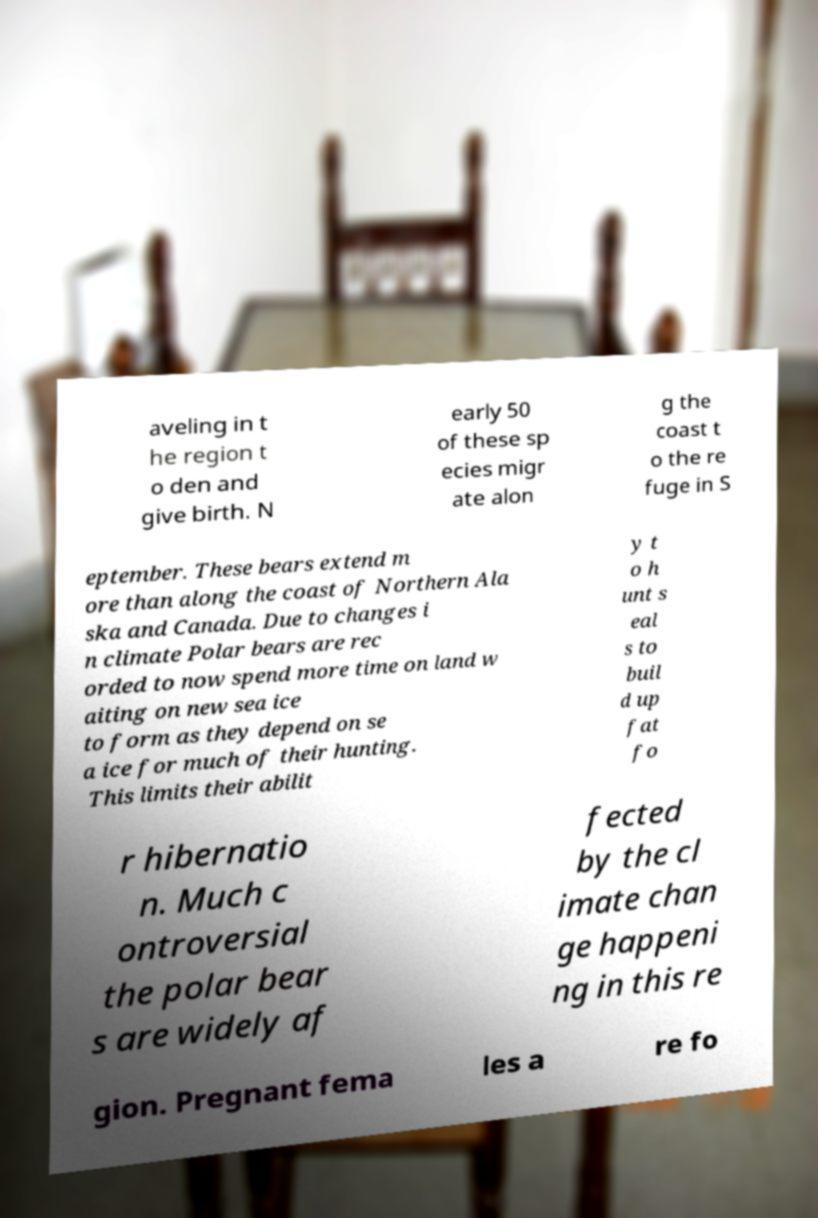Please identify and transcribe the text found in this image. aveling in t he region t o den and give birth. N early 50 of these sp ecies migr ate alon g the coast t o the re fuge in S eptember. These bears extend m ore than along the coast of Northern Ala ska and Canada. Due to changes i n climate Polar bears are rec orded to now spend more time on land w aiting on new sea ice to form as they depend on se a ice for much of their hunting. This limits their abilit y t o h unt s eal s to buil d up fat fo r hibernatio n. Much c ontroversial the polar bear s are widely af fected by the cl imate chan ge happeni ng in this re gion. Pregnant fema les a re fo 